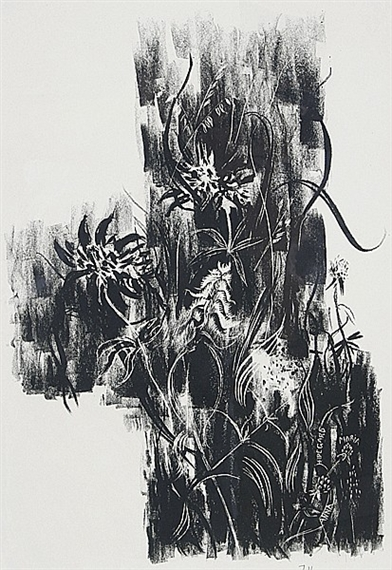What is this photo about? The image presents a compelling piece of abstract expressionist art, which is primarily monochromatic yet powerful in its visual impact. The stark contrast between the black and white intensifies the visual drama, while the swirling and jagged white lines across the dark background suggest dynamism and chaos. This type of artwork is known for evoking emotional responses without the need for realistic forms, focusing instead on the interplay of shapes and contrast to convey its message. The fluidity of lines and the texture indicate a likely use of lithography, a printmaking technique that allows for such crisp and intricate details. This piece might be interpreted as a reflection on natural forms or a deep, personal expression from the artist, leaving a lasting impression of both turmoil and beauty. 